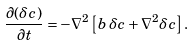Convert formula to latex. <formula><loc_0><loc_0><loc_500><loc_500>\frac { \partial ( \delta c ) } { \partial t } = - \nabla ^ { 2 } \left [ b \, \delta c + \nabla ^ { 2 } \delta c \right ] .</formula> 